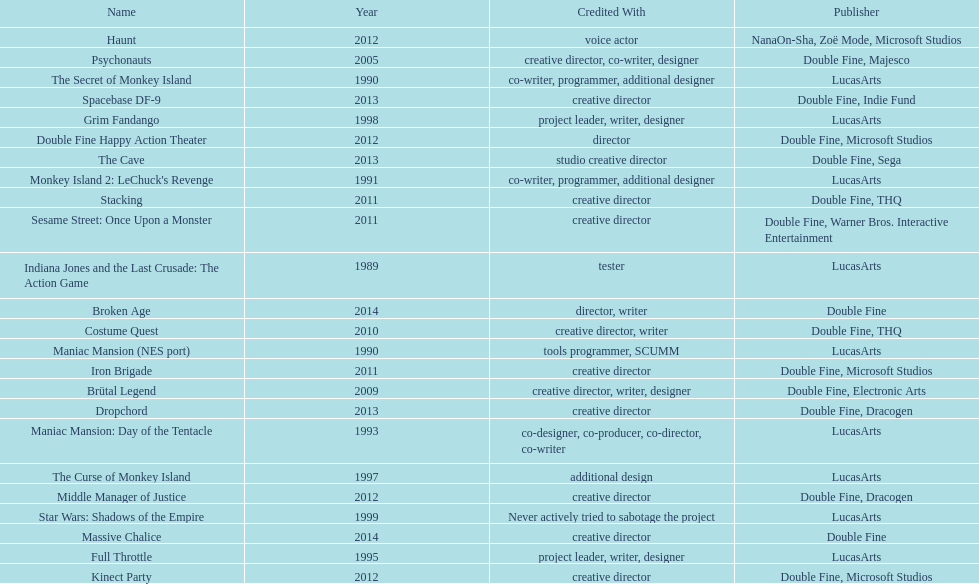Which game is credited with a creative director and warner bros. interactive entertainment as their creative director? Sesame Street: Once Upon a Monster. 